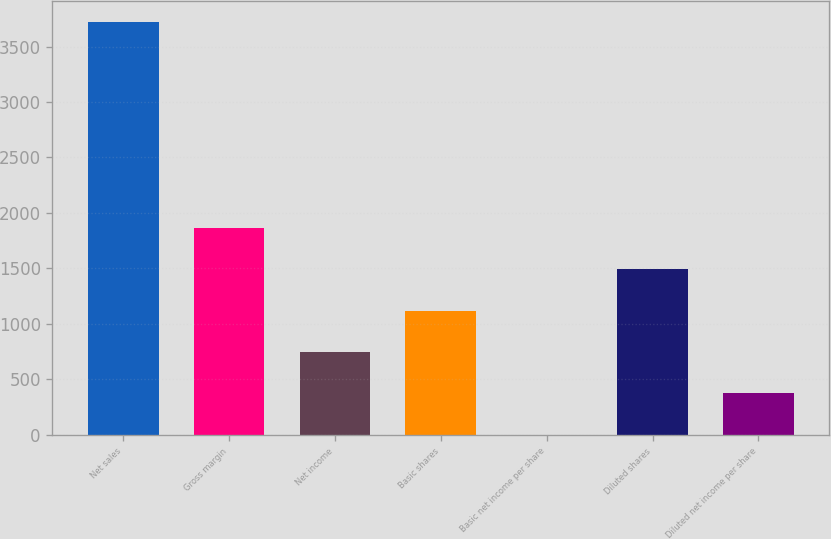Convert chart. <chart><loc_0><loc_0><loc_500><loc_500><bar_chart><fcel>Net sales<fcel>Gross margin<fcel>Net income<fcel>Basic shares<fcel>Basic net income per share<fcel>Diluted shares<fcel>Diluted net income per share<nl><fcel>3725<fcel>1862.87<fcel>745.61<fcel>1118.03<fcel>0.77<fcel>1490.45<fcel>373.19<nl></chart> 